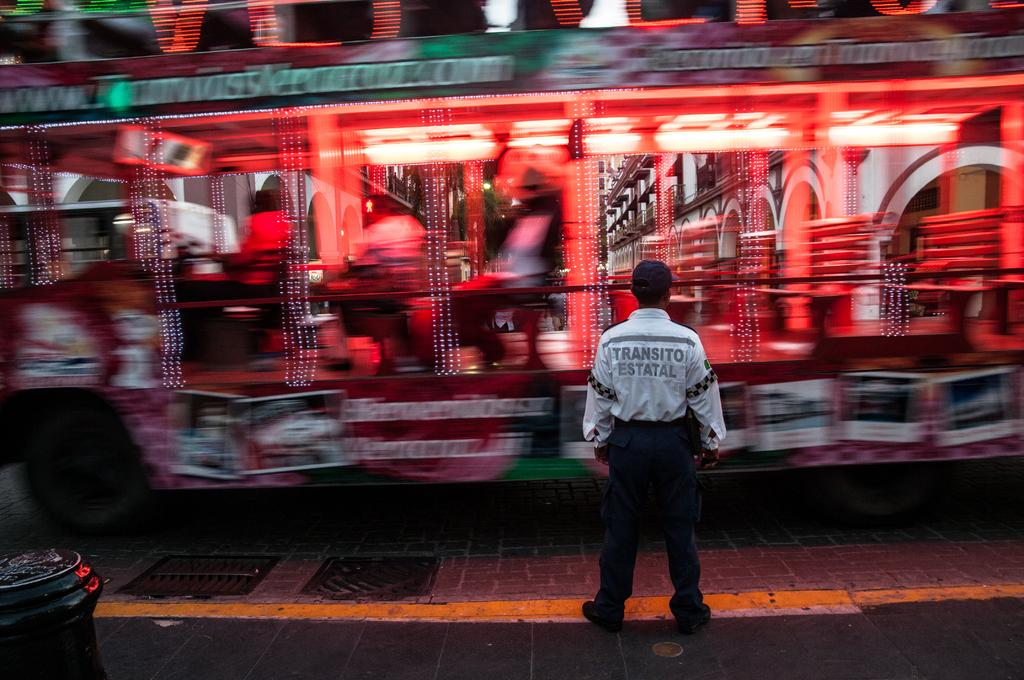What is the main subject of the image? There is a bus in the image. Where is the bus located? The bus is on the road. Can you describe the person in front of the bus? The person is standing in front of the bus and is wearing a cap. What else can be seen in the image? There is a bin in the image. What type of thunder can be heard in the image? There is no thunder present in the image, as it is a still image and does not contain any sound. 